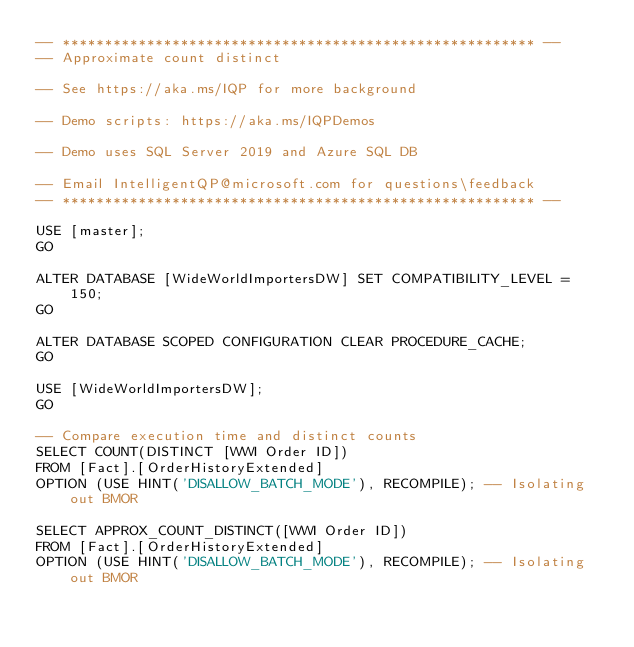Convert code to text. <code><loc_0><loc_0><loc_500><loc_500><_SQL_>-- ******************************************************** --
-- Approximate count distinct

-- See https://aka.ms/IQP for more background

-- Demo scripts: https://aka.ms/IQPDemos 

-- Demo uses SQL Server 2019 and Azure SQL DB

-- Email IntelligentQP@microsoft.com for questions\feedback
-- ******************************************************** --

USE [master];
GO

ALTER DATABASE [WideWorldImportersDW] SET COMPATIBILITY_LEVEL = 150;
GO

ALTER DATABASE SCOPED CONFIGURATION CLEAR PROCEDURE_CACHE;
GO

USE [WideWorldImportersDW];
GO

-- Compare execution time and distinct counts
SELECT COUNT(DISTINCT [WWI Order ID])
FROM [Fact].[OrderHistoryExtended]
OPTION (USE HINT('DISALLOW_BATCH_MODE'), RECOMPILE); -- Isolating out BMOR

SELECT APPROX_COUNT_DISTINCT([WWI Order ID])
FROM [Fact].[OrderHistoryExtended]
OPTION (USE HINT('DISALLOW_BATCH_MODE'), RECOMPILE); -- Isolating out BMOR

</code> 